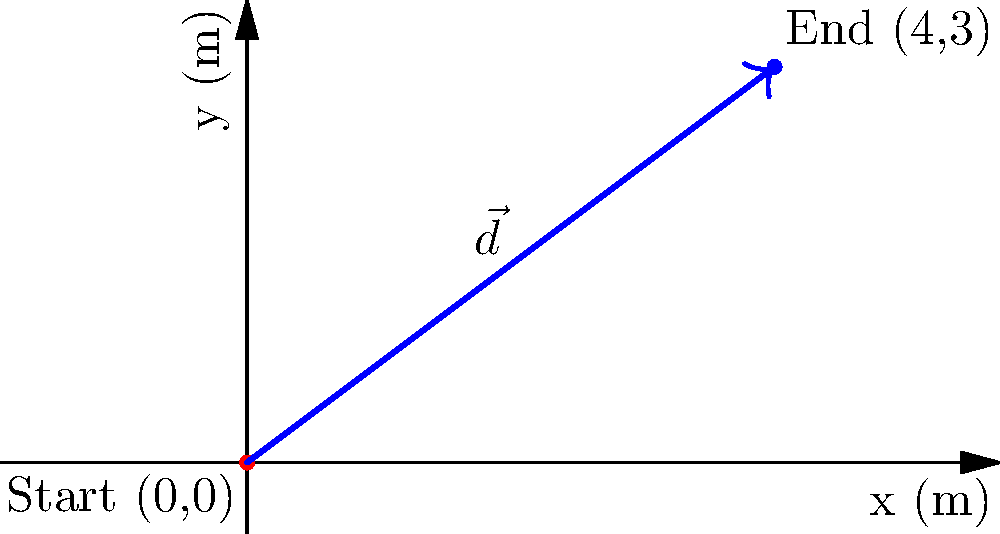In a regional equestrian competition, you're analyzing the displacement of your horse's jump. The horse starts at the origin (0,0) and lands at coordinates (4,3) meters. Calculate the displacement vector $\vec{d}$ of the horse's jump from start to finish. To find the displacement vector $\vec{d}$, we need to follow these steps:

1) The displacement vector is defined as the difference between the final position and the initial position.

2) Initial position: $(x_1, y_1) = (0, 0)$
   Final position: $(x_2, y_2) = (4, 3)$

3) The displacement vector $\vec{d}$ is calculated as:
   $\vec{d} = (x_2 - x_1, y_2 - y_1)$

4) Substituting the values:
   $\vec{d} = (4 - 0, 3 - 0) = (4, 3)$

5) Therefore, the displacement vector is $\vec{d} = 4\hat{i} + 3\hat{j}$ in standard unit vector notation, where $\hat{i}$ is the unit vector in the x-direction and $\hat{j}$ is the unit vector in the y-direction.

6) The magnitude of the displacement vector can be calculated using the Pythagorean theorem:
   $|\vec{d}| = \sqrt{4^2 + 3^2} = \sqrt{16 + 9} = \sqrt{25} = 5$ meters

7) The direction of the vector can be found using the arctangent function:
   $\theta = \tan^{-1}(\frac{3}{4}) \approx 36.87°$ above the positive x-axis

Thus, the horse's jump resulted in a displacement of 5 meters at an angle of approximately 36.87° above the horizontal.
Answer: $\vec{d} = 4\hat{i} + 3\hat{j}$ or $(4, 3)$ meters 